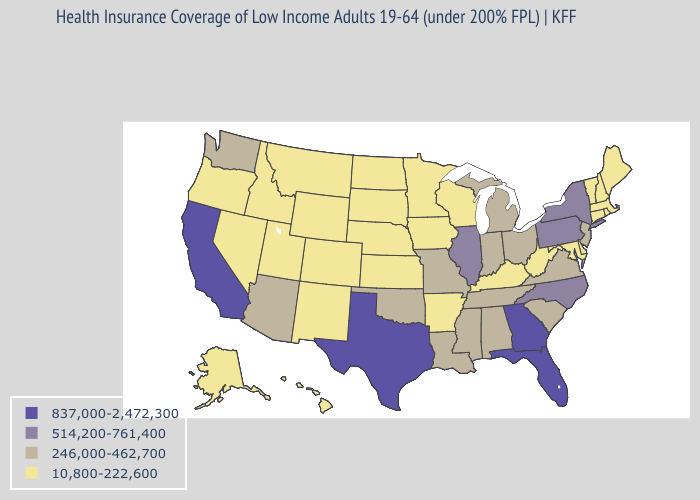Name the states that have a value in the range 837,000-2,472,300?
Short answer required. California, Florida, Georgia, Texas. Does South Dakota have a lower value than Wyoming?
Answer briefly. No. Does the first symbol in the legend represent the smallest category?
Concise answer only. No. How many symbols are there in the legend?
Write a very short answer. 4. Does Tennessee have a lower value than New York?
Give a very brief answer. Yes. What is the lowest value in the USA?
Quick response, please. 10,800-222,600. Name the states that have a value in the range 10,800-222,600?
Be succinct. Alaska, Arkansas, Colorado, Connecticut, Delaware, Hawaii, Idaho, Iowa, Kansas, Kentucky, Maine, Maryland, Massachusetts, Minnesota, Montana, Nebraska, Nevada, New Hampshire, New Mexico, North Dakota, Oregon, Rhode Island, South Dakota, Utah, Vermont, West Virginia, Wisconsin, Wyoming. Name the states that have a value in the range 246,000-462,700?
Answer briefly. Alabama, Arizona, Indiana, Louisiana, Michigan, Mississippi, Missouri, New Jersey, Ohio, Oklahoma, South Carolina, Tennessee, Virginia, Washington. Which states have the lowest value in the MidWest?
Be succinct. Iowa, Kansas, Minnesota, Nebraska, North Dakota, South Dakota, Wisconsin. Name the states that have a value in the range 10,800-222,600?
Write a very short answer. Alaska, Arkansas, Colorado, Connecticut, Delaware, Hawaii, Idaho, Iowa, Kansas, Kentucky, Maine, Maryland, Massachusetts, Minnesota, Montana, Nebraska, Nevada, New Hampshire, New Mexico, North Dakota, Oregon, Rhode Island, South Dakota, Utah, Vermont, West Virginia, Wisconsin, Wyoming. Name the states that have a value in the range 246,000-462,700?
Be succinct. Alabama, Arizona, Indiana, Louisiana, Michigan, Mississippi, Missouri, New Jersey, Ohio, Oklahoma, South Carolina, Tennessee, Virginia, Washington. What is the value of California?
Answer briefly. 837,000-2,472,300. What is the highest value in the West ?
Write a very short answer. 837,000-2,472,300. Among the states that border Maryland , does Delaware have the highest value?
Be succinct. No. 